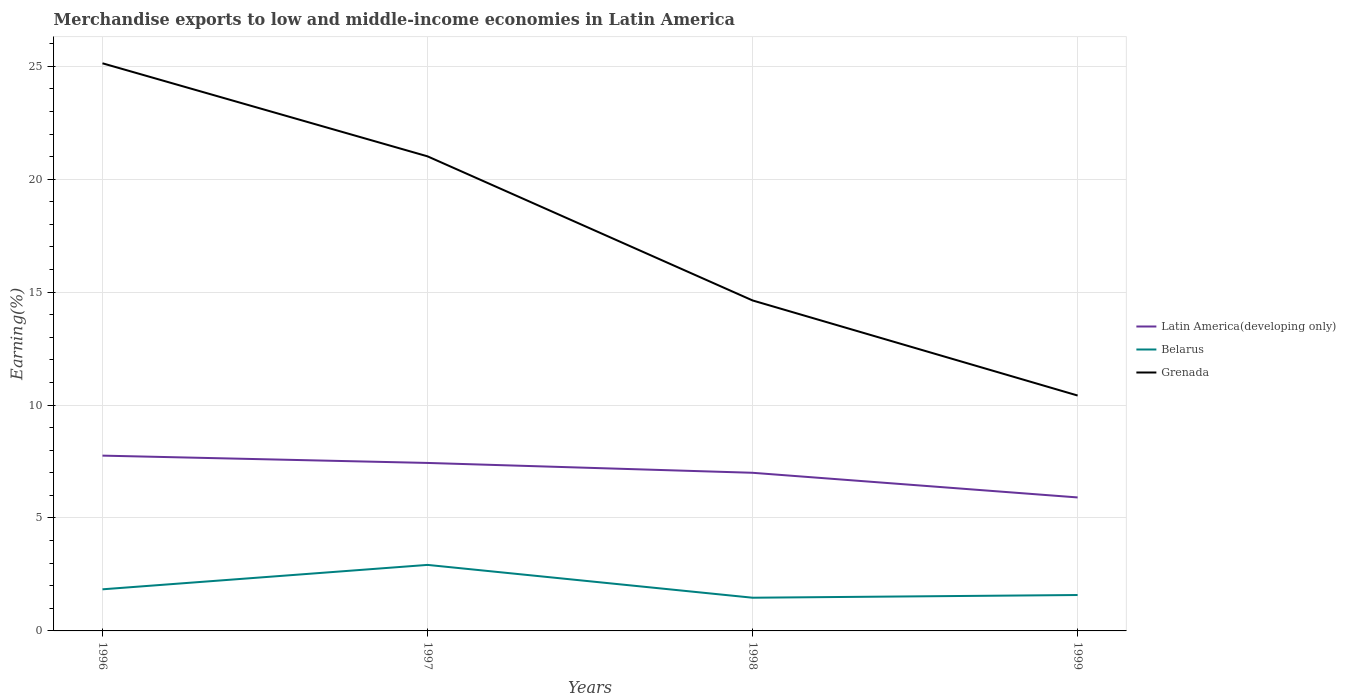How many different coloured lines are there?
Offer a terse response. 3. Does the line corresponding to Belarus intersect with the line corresponding to Latin America(developing only)?
Provide a short and direct response. No. Across all years, what is the maximum percentage of amount earned from merchandise exports in Belarus?
Your answer should be very brief. 1.47. What is the total percentage of amount earned from merchandise exports in Latin America(developing only) in the graph?
Your answer should be very brief. 1.09. What is the difference between the highest and the second highest percentage of amount earned from merchandise exports in Grenada?
Keep it short and to the point. 14.71. How many lines are there?
Your answer should be very brief. 3. How many years are there in the graph?
Ensure brevity in your answer.  4. Does the graph contain any zero values?
Your answer should be very brief. No. What is the title of the graph?
Provide a short and direct response. Merchandise exports to low and middle-income economies in Latin America. What is the label or title of the X-axis?
Your answer should be very brief. Years. What is the label or title of the Y-axis?
Provide a succinct answer. Earning(%). What is the Earning(%) in Latin America(developing only) in 1996?
Your answer should be very brief. 7.76. What is the Earning(%) of Belarus in 1996?
Provide a short and direct response. 1.84. What is the Earning(%) in Grenada in 1996?
Give a very brief answer. 25.13. What is the Earning(%) in Latin America(developing only) in 1997?
Ensure brevity in your answer.  7.44. What is the Earning(%) of Belarus in 1997?
Make the answer very short. 2.92. What is the Earning(%) of Grenada in 1997?
Keep it short and to the point. 21.01. What is the Earning(%) in Latin America(developing only) in 1998?
Provide a short and direct response. 7. What is the Earning(%) of Belarus in 1998?
Provide a short and direct response. 1.47. What is the Earning(%) in Grenada in 1998?
Offer a very short reply. 14.63. What is the Earning(%) of Latin America(developing only) in 1999?
Provide a short and direct response. 5.91. What is the Earning(%) of Belarus in 1999?
Offer a terse response. 1.59. What is the Earning(%) of Grenada in 1999?
Your answer should be very brief. 10.42. Across all years, what is the maximum Earning(%) of Latin America(developing only)?
Make the answer very short. 7.76. Across all years, what is the maximum Earning(%) in Belarus?
Provide a succinct answer. 2.92. Across all years, what is the maximum Earning(%) of Grenada?
Give a very brief answer. 25.13. Across all years, what is the minimum Earning(%) of Latin America(developing only)?
Provide a succinct answer. 5.91. Across all years, what is the minimum Earning(%) of Belarus?
Offer a terse response. 1.47. Across all years, what is the minimum Earning(%) of Grenada?
Ensure brevity in your answer.  10.42. What is the total Earning(%) of Latin America(developing only) in the graph?
Offer a terse response. 28.11. What is the total Earning(%) in Belarus in the graph?
Make the answer very short. 7.82. What is the total Earning(%) in Grenada in the graph?
Ensure brevity in your answer.  71.2. What is the difference between the Earning(%) in Latin America(developing only) in 1996 and that in 1997?
Keep it short and to the point. 0.32. What is the difference between the Earning(%) in Belarus in 1996 and that in 1997?
Provide a short and direct response. -1.08. What is the difference between the Earning(%) in Grenada in 1996 and that in 1997?
Provide a short and direct response. 4.12. What is the difference between the Earning(%) in Latin America(developing only) in 1996 and that in 1998?
Your response must be concise. 0.76. What is the difference between the Earning(%) in Belarus in 1996 and that in 1998?
Offer a very short reply. 0.37. What is the difference between the Earning(%) of Grenada in 1996 and that in 1998?
Your answer should be very brief. 10.5. What is the difference between the Earning(%) in Latin America(developing only) in 1996 and that in 1999?
Keep it short and to the point. 1.85. What is the difference between the Earning(%) of Belarus in 1996 and that in 1999?
Keep it short and to the point. 0.25. What is the difference between the Earning(%) in Grenada in 1996 and that in 1999?
Give a very brief answer. 14.71. What is the difference between the Earning(%) of Latin America(developing only) in 1997 and that in 1998?
Provide a short and direct response. 0.44. What is the difference between the Earning(%) of Belarus in 1997 and that in 1998?
Your response must be concise. 1.45. What is the difference between the Earning(%) of Grenada in 1997 and that in 1998?
Provide a short and direct response. 6.38. What is the difference between the Earning(%) in Latin America(developing only) in 1997 and that in 1999?
Make the answer very short. 1.53. What is the difference between the Earning(%) of Belarus in 1997 and that in 1999?
Provide a short and direct response. 1.33. What is the difference between the Earning(%) of Grenada in 1997 and that in 1999?
Offer a terse response. 10.59. What is the difference between the Earning(%) of Latin America(developing only) in 1998 and that in 1999?
Provide a short and direct response. 1.09. What is the difference between the Earning(%) in Belarus in 1998 and that in 1999?
Your response must be concise. -0.12. What is the difference between the Earning(%) of Grenada in 1998 and that in 1999?
Provide a short and direct response. 4.21. What is the difference between the Earning(%) in Latin America(developing only) in 1996 and the Earning(%) in Belarus in 1997?
Offer a terse response. 4.84. What is the difference between the Earning(%) of Latin America(developing only) in 1996 and the Earning(%) of Grenada in 1997?
Your answer should be compact. -13.25. What is the difference between the Earning(%) in Belarus in 1996 and the Earning(%) in Grenada in 1997?
Your answer should be very brief. -19.17. What is the difference between the Earning(%) in Latin America(developing only) in 1996 and the Earning(%) in Belarus in 1998?
Your answer should be very brief. 6.29. What is the difference between the Earning(%) in Latin America(developing only) in 1996 and the Earning(%) in Grenada in 1998?
Your answer should be compact. -6.87. What is the difference between the Earning(%) of Belarus in 1996 and the Earning(%) of Grenada in 1998?
Your response must be concise. -12.79. What is the difference between the Earning(%) of Latin America(developing only) in 1996 and the Earning(%) of Belarus in 1999?
Your response must be concise. 6.17. What is the difference between the Earning(%) in Latin America(developing only) in 1996 and the Earning(%) in Grenada in 1999?
Provide a short and direct response. -2.66. What is the difference between the Earning(%) in Belarus in 1996 and the Earning(%) in Grenada in 1999?
Your response must be concise. -8.58. What is the difference between the Earning(%) in Latin America(developing only) in 1997 and the Earning(%) in Belarus in 1998?
Ensure brevity in your answer.  5.97. What is the difference between the Earning(%) in Latin America(developing only) in 1997 and the Earning(%) in Grenada in 1998?
Provide a short and direct response. -7.19. What is the difference between the Earning(%) in Belarus in 1997 and the Earning(%) in Grenada in 1998?
Ensure brevity in your answer.  -11.71. What is the difference between the Earning(%) of Latin America(developing only) in 1997 and the Earning(%) of Belarus in 1999?
Your answer should be compact. 5.85. What is the difference between the Earning(%) of Latin America(developing only) in 1997 and the Earning(%) of Grenada in 1999?
Provide a short and direct response. -2.98. What is the difference between the Earning(%) in Belarus in 1997 and the Earning(%) in Grenada in 1999?
Your answer should be very brief. -7.5. What is the difference between the Earning(%) of Latin America(developing only) in 1998 and the Earning(%) of Belarus in 1999?
Your answer should be very brief. 5.41. What is the difference between the Earning(%) of Latin America(developing only) in 1998 and the Earning(%) of Grenada in 1999?
Ensure brevity in your answer.  -3.42. What is the difference between the Earning(%) in Belarus in 1998 and the Earning(%) in Grenada in 1999?
Your answer should be very brief. -8.95. What is the average Earning(%) in Latin America(developing only) per year?
Make the answer very short. 7.03. What is the average Earning(%) in Belarus per year?
Your answer should be compact. 1.96. What is the average Earning(%) in Grenada per year?
Ensure brevity in your answer.  17.8. In the year 1996, what is the difference between the Earning(%) of Latin America(developing only) and Earning(%) of Belarus?
Make the answer very short. 5.92. In the year 1996, what is the difference between the Earning(%) in Latin America(developing only) and Earning(%) in Grenada?
Provide a short and direct response. -17.37. In the year 1996, what is the difference between the Earning(%) of Belarus and Earning(%) of Grenada?
Your answer should be very brief. -23.29. In the year 1997, what is the difference between the Earning(%) in Latin America(developing only) and Earning(%) in Belarus?
Provide a short and direct response. 4.51. In the year 1997, what is the difference between the Earning(%) in Latin America(developing only) and Earning(%) in Grenada?
Keep it short and to the point. -13.57. In the year 1997, what is the difference between the Earning(%) of Belarus and Earning(%) of Grenada?
Your response must be concise. -18.09. In the year 1998, what is the difference between the Earning(%) of Latin America(developing only) and Earning(%) of Belarus?
Make the answer very short. 5.53. In the year 1998, what is the difference between the Earning(%) of Latin America(developing only) and Earning(%) of Grenada?
Make the answer very short. -7.63. In the year 1998, what is the difference between the Earning(%) in Belarus and Earning(%) in Grenada?
Offer a very short reply. -13.16. In the year 1999, what is the difference between the Earning(%) of Latin America(developing only) and Earning(%) of Belarus?
Provide a short and direct response. 4.32. In the year 1999, what is the difference between the Earning(%) in Latin America(developing only) and Earning(%) in Grenada?
Provide a short and direct response. -4.51. In the year 1999, what is the difference between the Earning(%) in Belarus and Earning(%) in Grenada?
Give a very brief answer. -8.83. What is the ratio of the Earning(%) in Latin America(developing only) in 1996 to that in 1997?
Make the answer very short. 1.04. What is the ratio of the Earning(%) in Belarus in 1996 to that in 1997?
Offer a terse response. 0.63. What is the ratio of the Earning(%) in Grenada in 1996 to that in 1997?
Keep it short and to the point. 1.2. What is the ratio of the Earning(%) in Latin America(developing only) in 1996 to that in 1998?
Give a very brief answer. 1.11. What is the ratio of the Earning(%) in Belarus in 1996 to that in 1998?
Keep it short and to the point. 1.25. What is the ratio of the Earning(%) of Grenada in 1996 to that in 1998?
Keep it short and to the point. 1.72. What is the ratio of the Earning(%) in Latin America(developing only) in 1996 to that in 1999?
Your response must be concise. 1.31. What is the ratio of the Earning(%) of Belarus in 1996 to that in 1999?
Your answer should be compact. 1.16. What is the ratio of the Earning(%) in Grenada in 1996 to that in 1999?
Your answer should be very brief. 2.41. What is the ratio of the Earning(%) of Latin America(developing only) in 1997 to that in 1998?
Keep it short and to the point. 1.06. What is the ratio of the Earning(%) in Belarus in 1997 to that in 1998?
Offer a very short reply. 1.99. What is the ratio of the Earning(%) of Grenada in 1997 to that in 1998?
Offer a very short reply. 1.44. What is the ratio of the Earning(%) of Latin America(developing only) in 1997 to that in 1999?
Your answer should be compact. 1.26. What is the ratio of the Earning(%) of Belarus in 1997 to that in 1999?
Your response must be concise. 1.84. What is the ratio of the Earning(%) in Grenada in 1997 to that in 1999?
Provide a succinct answer. 2.02. What is the ratio of the Earning(%) in Latin America(developing only) in 1998 to that in 1999?
Offer a terse response. 1.18. What is the ratio of the Earning(%) in Belarus in 1998 to that in 1999?
Make the answer very short. 0.92. What is the ratio of the Earning(%) of Grenada in 1998 to that in 1999?
Offer a very short reply. 1.4. What is the difference between the highest and the second highest Earning(%) in Latin America(developing only)?
Provide a short and direct response. 0.32. What is the difference between the highest and the second highest Earning(%) of Belarus?
Your response must be concise. 1.08. What is the difference between the highest and the second highest Earning(%) of Grenada?
Provide a short and direct response. 4.12. What is the difference between the highest and the lowest Earning(%) of Latin America(developing only)?
Provide a short and direct response. 1.85. What is the difference between the highest and the lowest Earning(%) in Belarus?
Provide a short and direct response. 1.45. What is the difference between the highest and the lowest Earning(%) of Grenada?
Your answer should be compact. 14.71. 